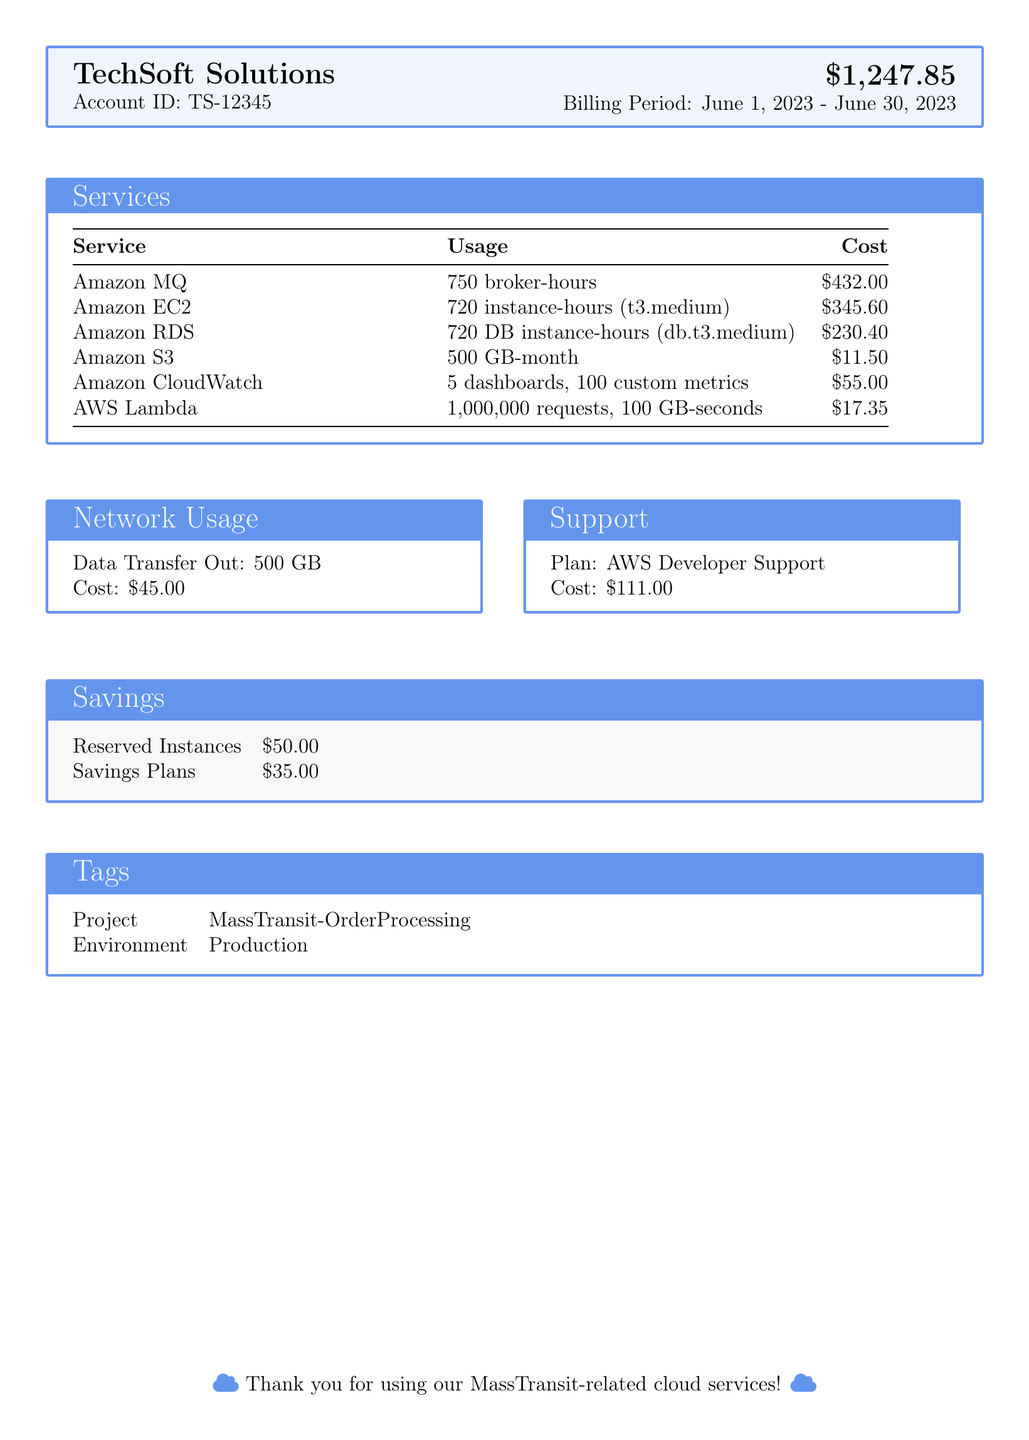What is the total cost of the bill? The total cost of the bill is shown prominently in the document as $1,247.85.
Answer: $1,247.85 What is the billing period? The billing period is mentioned in the document as spanning from June 1, 2023, to June 30, 2023.
Answer: June 1, 2023 - June 30, 2023 How many broker-hours of Amazon MQ were used? The document specifies the usage for Amazon MQ as 750 broker-hours.
Answer: 750 broker-hours What is the cost of Amazon EC2? The cost of Amazon EC2 is provided in the services table, and it is $345.60.
Answer: $345.60 What type of AWS support plan is listed? The document indicates the support plan as AWS Developer Support.
Answer: AWS Developer Support How much was saved from Reserved Instances? The document lists the savings from Reserved Instances as $50.00.
Answer: $50.00 What is the usage of Amazon S3? The document states the usage of Amazon S3 as 500 GB-month.
Answer: 500 GB-month What project tag is noted in the document? The project tag in the document is mentioned as MassTransit-OrderProcessing.
Answer: MassTransit-OrderProcessing What is the cost of data transfer out? The document indicates that the cost of data transfer out is $45.00.
Answer: $45.00 